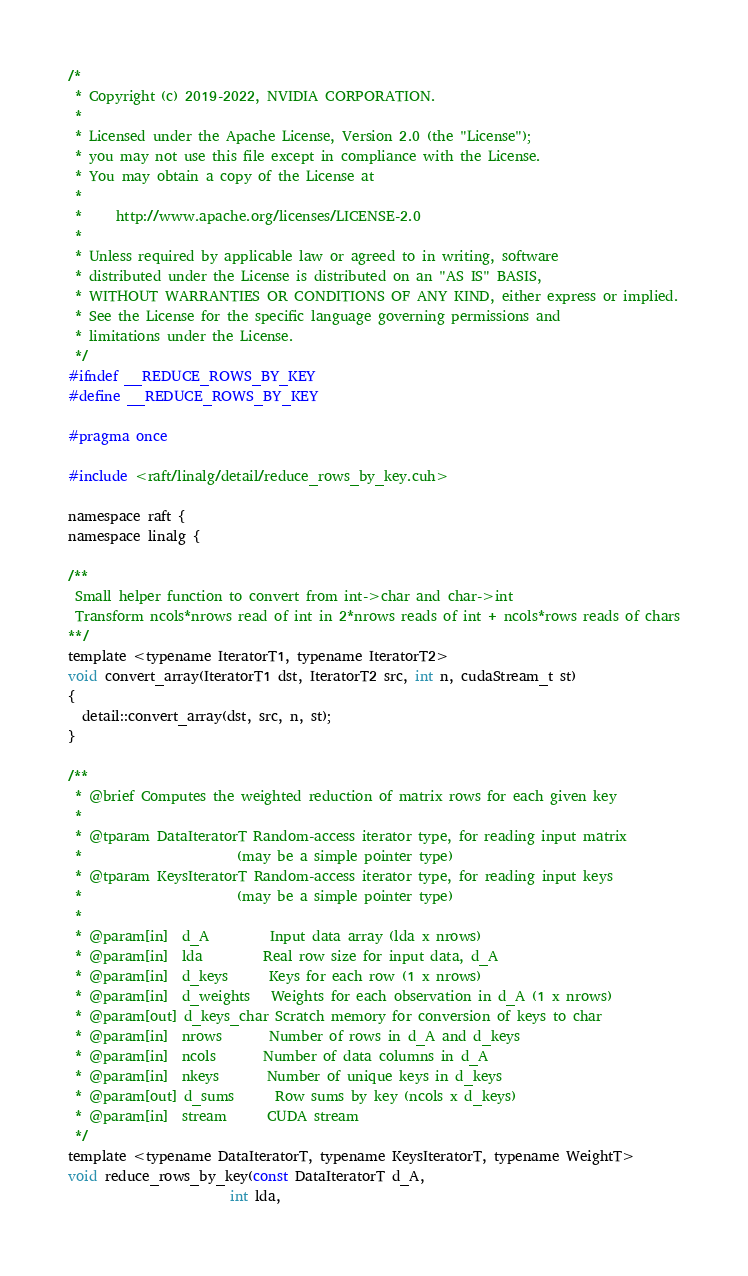Convert code to text. <code><loc_0><loc_0><loc_500><loc_500><_Cuda_>/*
 * Copyright (c) 2019-2022, NVIDIA CORPORATION.
 *
 * Licensed under the Apache License, Version 2.0 (the "License");
 * you may not use this file except in compliance with the License.
 * You may obtain a copy of the License at
 *
 *     http://www.apache.org/licenses/LICENSE-2.0
 *
 * Unless required by applicable law or agreed to in writing, software
 * distributed under the License is distributed on an "AS IS" BASIS,
 * WITHOUT WARRANTIES OR CONDITIONS OF ANY KIND, either express or implied.
 * See the License for the specific language governing permissions and
 * limitations under the License.
 */
#ifndef __REDUCE_ROWS_BY_KEY
#define __REDUCE_ROWS_BY_KEY

#pragma once

#include <raft/linalg/detail/reduce_rows_by_key.cuh>

namespace raft {
namespace linalg {

/**
 Small helper function to convert from int->char and char->int
 Transform ncols*nrows read of int in 2*nrows reads of int + ncols*rows reads of chars
**/
template <typename IteratorT1, typename IteratorT2>
void convert_array(IteratorT1 dst, IteratorT2 src, int n, cudaStream_t st)
{
  detail::convert_array(dst, src, n, st);
}

/**
 * @brief Computes the weighted reduction of matrix rows for each given key
 *
 * @tparam DataIteratorT Random-access iterator type, for reading input matrix
 *                       (may be a simple pointer type)
 * @tparam KeysIteratorT Random-access iterator type, for reading input keys
 *                       (may be a simple pointer type)
 *
 * @param[in]  d_A         Input data array (lda x nrows)
 * @param[in]  lda         Real row size for input data, d_A
 * @param[in]  d_keys      Keys for each row (1 x nrows)
 * @param[in]  d_weights   Weights for each observation in d_A (1 x nrows)
 * @param[out] d_keys_char Scratch memory for conversion of keys to char
 * @param[in]  nrows       Number of rows in d_A and d_keys
 * @param[in]  ncols       Number of data columns in d_A
 * @param[in]  nkeys       Number of unique keys in d_keys
 * @param[out] d_sums      Row sums by key (ncols x d_keys)
 * @param[in]  stream      CUDA stream
 */
template <typename DataIteratorT, typename KeysIteratorT, typename WeightT>
void reduce_rows_by_key(const DataIteratorT d_A,
                        int lda,</code> 